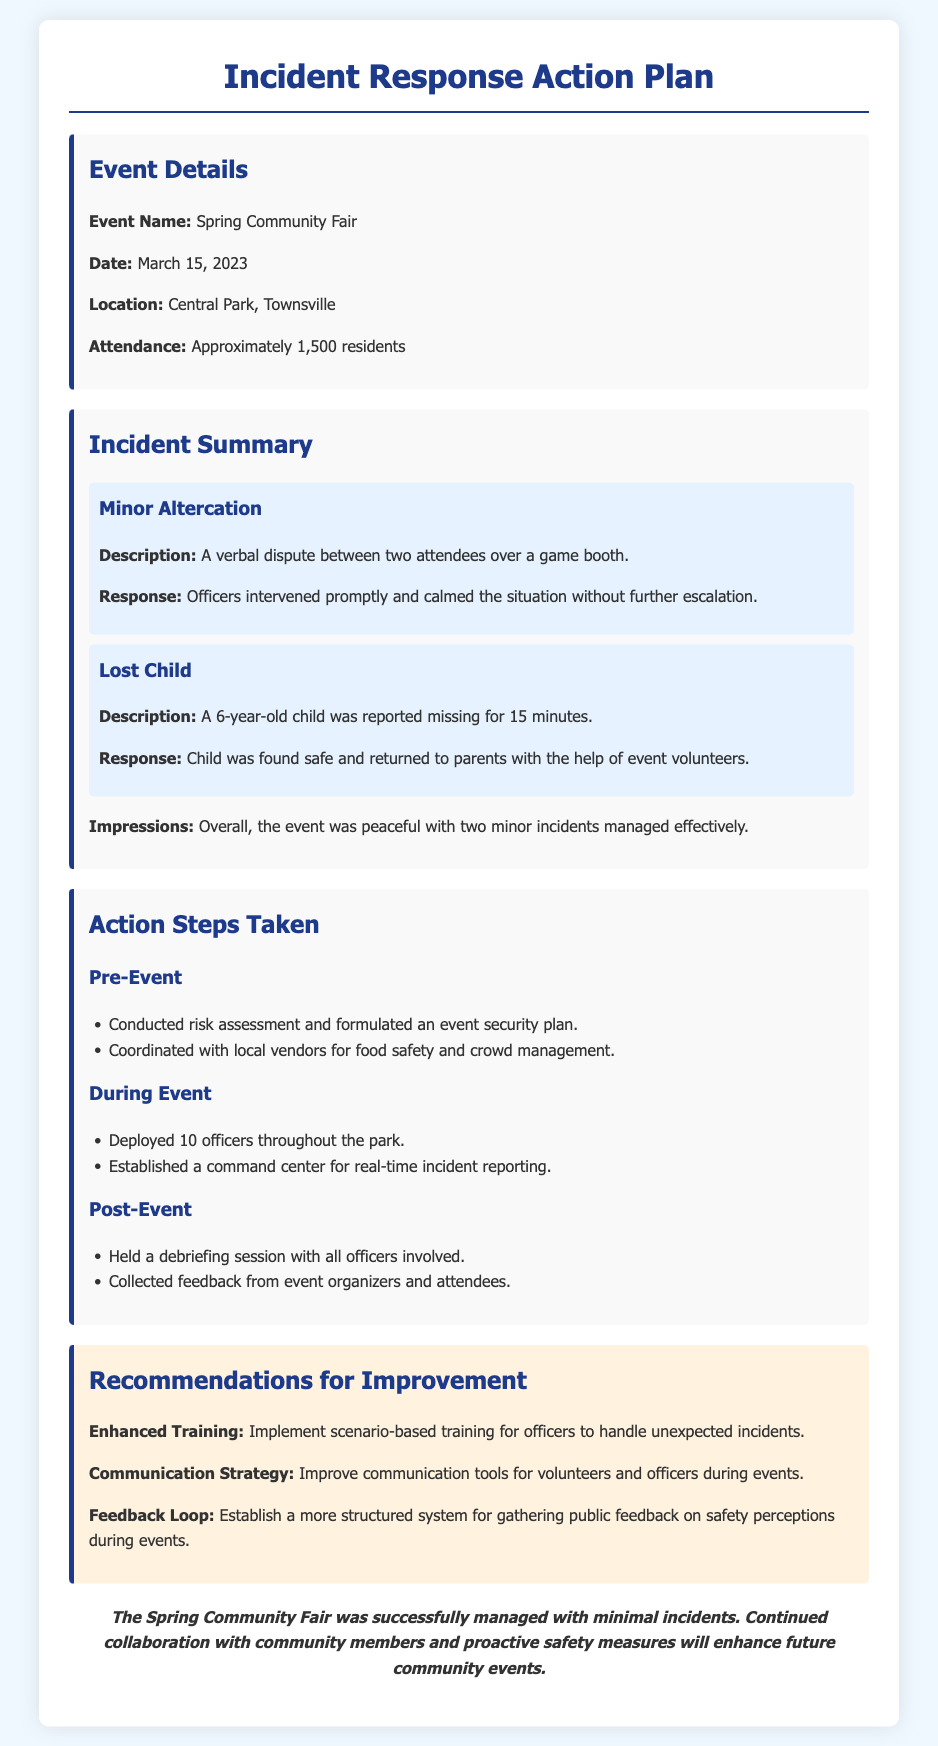what was the event name? The event name is stated clearly in the document under Event Details.
Answer: Spring Community Fair when did the event take place? The date of the event is specified in the Event Details section.
Answer: March 15, 2023 where was the event held? The location of the event is mentioned in the Event Details section.
Answer: Central Park, Townsville how many attendees were there? The attendance number is provided in the Event Details section.
Answer: Approximately 1,500 residents how many officers were deployed during the event? The number of officers during the event is listed in the Action Steps Taken section.
Answer: 10 officers what type of incident involved a child? The specific incident involving a child is described under Incident Summary.
Answer: Lost Child what was one recommendation for improvement? The recommendations for improvement can be found in the corresponding section.
Answer: Enhanced Training what was established for real-time incident reporting during the event? The document specifies what was set up during the event for reporting.
Answer: Command center overall, how was the event described? The assessment of the event's management is found in the Incident Summary section.
Answer: Peaceful 